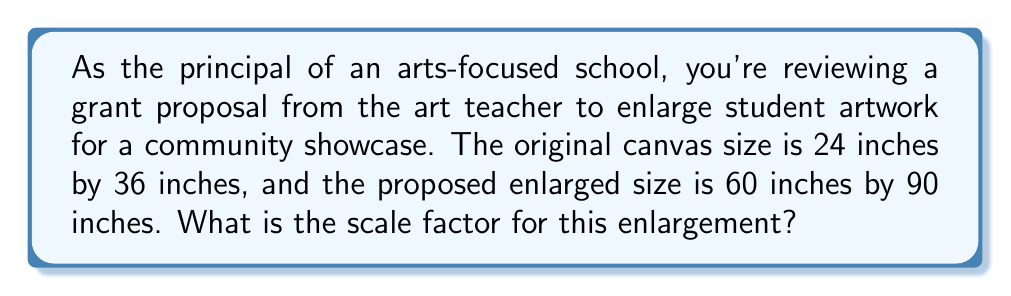Provide a solution to this math problem. To find the scale factor for enlarging artwork, we need to compare the dimensions of the enlarged version to the original. Let's approach this step-by-step:

1. Identify the original and new dimensions:
   Original: 24 inches × 36 inches
   Enlarged: 60 inches × 90 inches

2. Calculate the ratio of new to original dimensions for both width and height:

   For width: $\frac{\text{New width}}{\text{Original width}} = \frac{60}{24} = \frac{5}{2} = 2.5$
   
   For height: $\frac{\text{New height}}{\text{Original height}} = \frac{90}{36} = \frac{5}{2} = 2.5$

3. Verify that the ratios are the same for both dimensions. This ensures the enlargement is proportional.

4. The scale factor is this common ratio: 2.5

This means that each dimension of the original artwork will be multiplied by 2.5 to achieve the enlarged size.

We can verify this:
$24 \times 2.5 = 60$ inches (new width)
$36 \times 2.5 = 90$ inches (new height)

The scale factor of 2.5 indicates that the enlarged artwork will be 2.5 times larger in each dimension compared to the original.
Answer: The scale factor for enlarging the artwork is 2.5. 